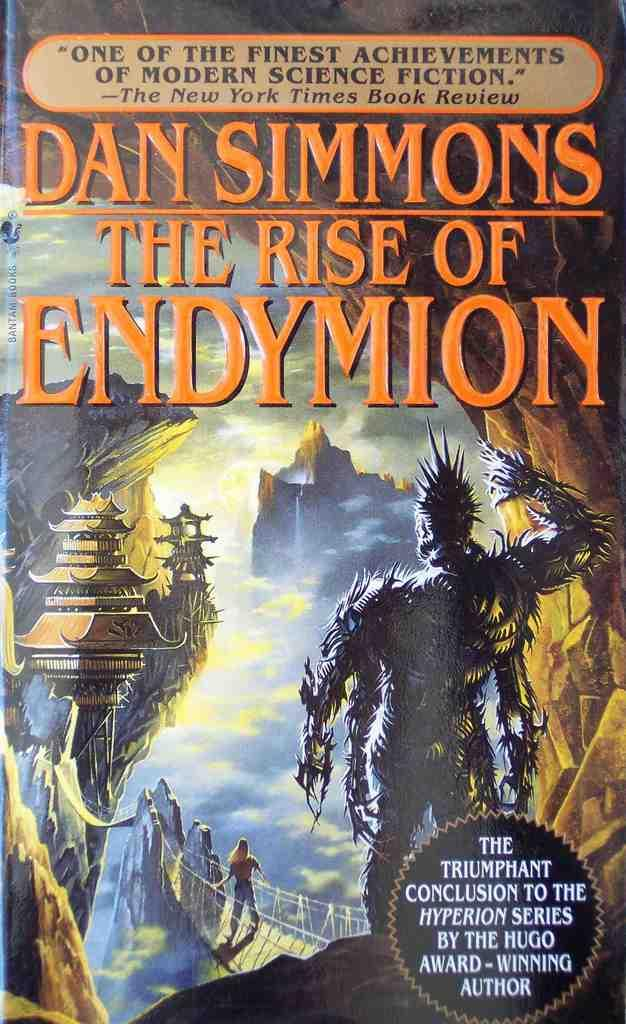<image>
Share a concise interpretation of the image provided. A book by Dan Simmons has a review by The New York Times on the cover. 